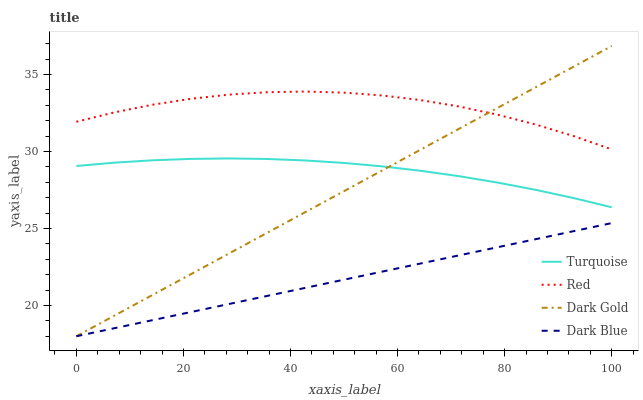Does Dark Blue have the minimum area under the curve?
Answer yes or no. Yes. Does Red have the maximum area under the curve?
Answer yes or no. Yes. Does Turquoise have the minimum area under the curve?
Answer yes or no. No. Does Turquoise have the maximum area under the curve?
Answer yes or no. No. Is Dark Blue the smoothest?
Answer yes or no. Yes. Is Red the roughest?
Answer yes or no. Yes. Is Turquoise the smoothest?
Answer yes or no. No. Is Turquoise the roughest?
Answer yes or no. No. Does Turquoise have the lowest value?
Answer yes or no. No. Does Dark Gold have the highest value?
Answer yes or no. Yes. Does Turquoise have the highest value?
Answer yes or no. No. Is Dark Blue less than Red?
Answer yes or no. Yes. Is Red greater than Turquoise?
Answer yes or no. Yes. Does Dark Blue intersect Dark Gold?
Answer yes or no. Yes. Is Dark Blue less than Dark Gold?
Answer yes or no. No. Is Dark Blue greater than Dark Gold?
Answer yes or no. No. Does Dark Blue intersect Red?
Answer yes or no. No. 